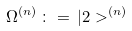<formula> <loc_0><loc_0><loc_500><loc_500>\Omega ^ { ( n ) } \, \colon = \, | 2 > ^ { ( n ) }</formula> 